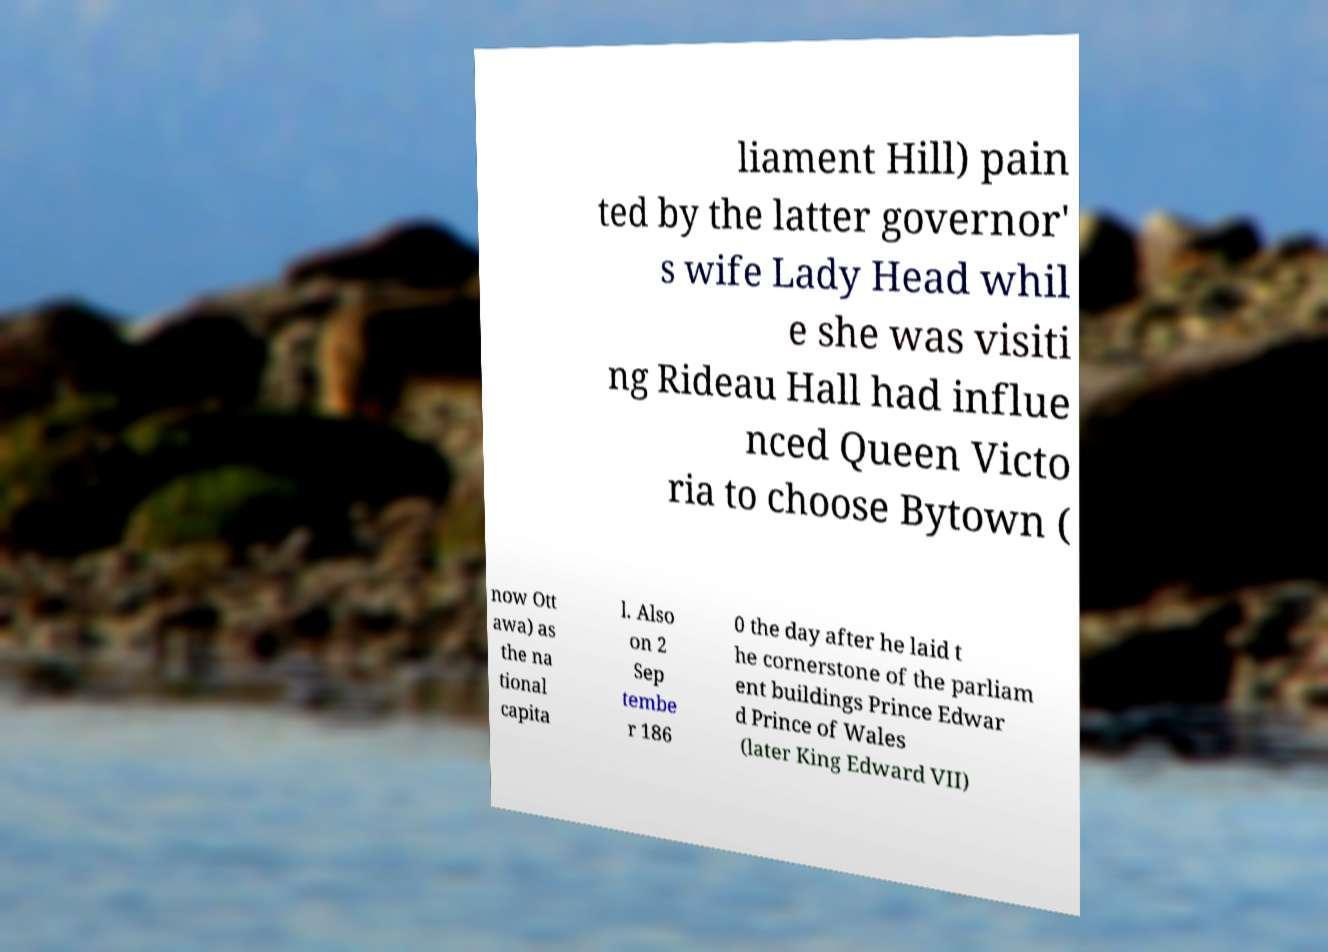Please identify and transcribe the text found in this image. liament Hill) pain ted by the latter governor' s wife Lady Head whil e she was visiti ng Rideau Hall had influe nced Queen Victo ria to choose Bytown ( now Ott awa) as the na tional capita l. Also on 2 Sep tembe r 186 0 the day after he laid t he cornerstone of the parliam ent buildings Prince Edwar d Prince of Wales (later King Edward VII) 